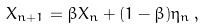Convert formula to latex. <formula><loc_0><loc_0><loc_500><loc_500>X _ { n + 1 } = \beta X _ { n } + ( 1 - \beta ) \eta _ { n } \, ,</formula> 